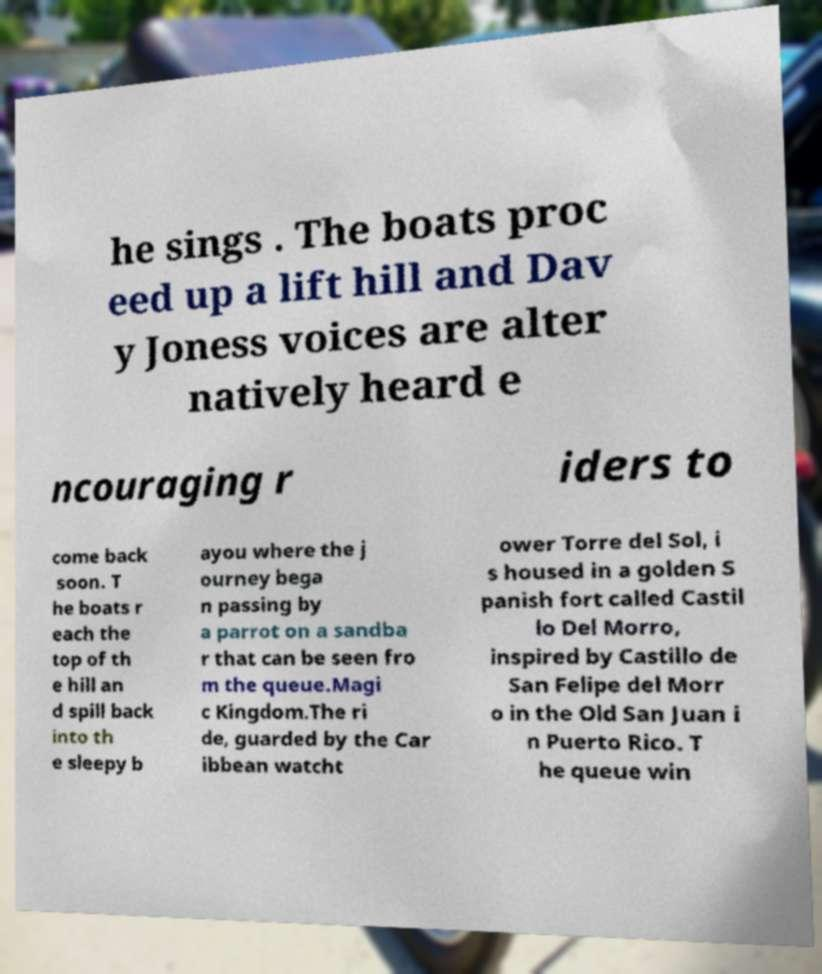What messages or text are displayed in this image? I need them in a readable, typed format. he sings . The boats proc eed up a lift hill and Dav y Joness voices are alter natively heard e ncouraging r iders to come back soon. T he boats r each the top of th e hill an d spill back into th e sleepy b ayou where the j ourney bega n passing by a parrot on a sandba r that can be seen fro m the queue.Magi c Kingdom.The ri de, guarded by the Car ibbean watcht ower Torre del Sol, i s housed in a golden S panish fort called Castil lo Del Morro, inspired by Castillo de San Felipe del Morr o in the Old San Juan i n Puerto Rico. T he queue win 